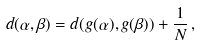<formula> <loc_0><loc_0><loc_500><loc_500>d ( \alpha , \beta ) = d ( g ( \alpha ) , g ( \beta ) ) + \frac { 1 } { N } \, ,</formula> 